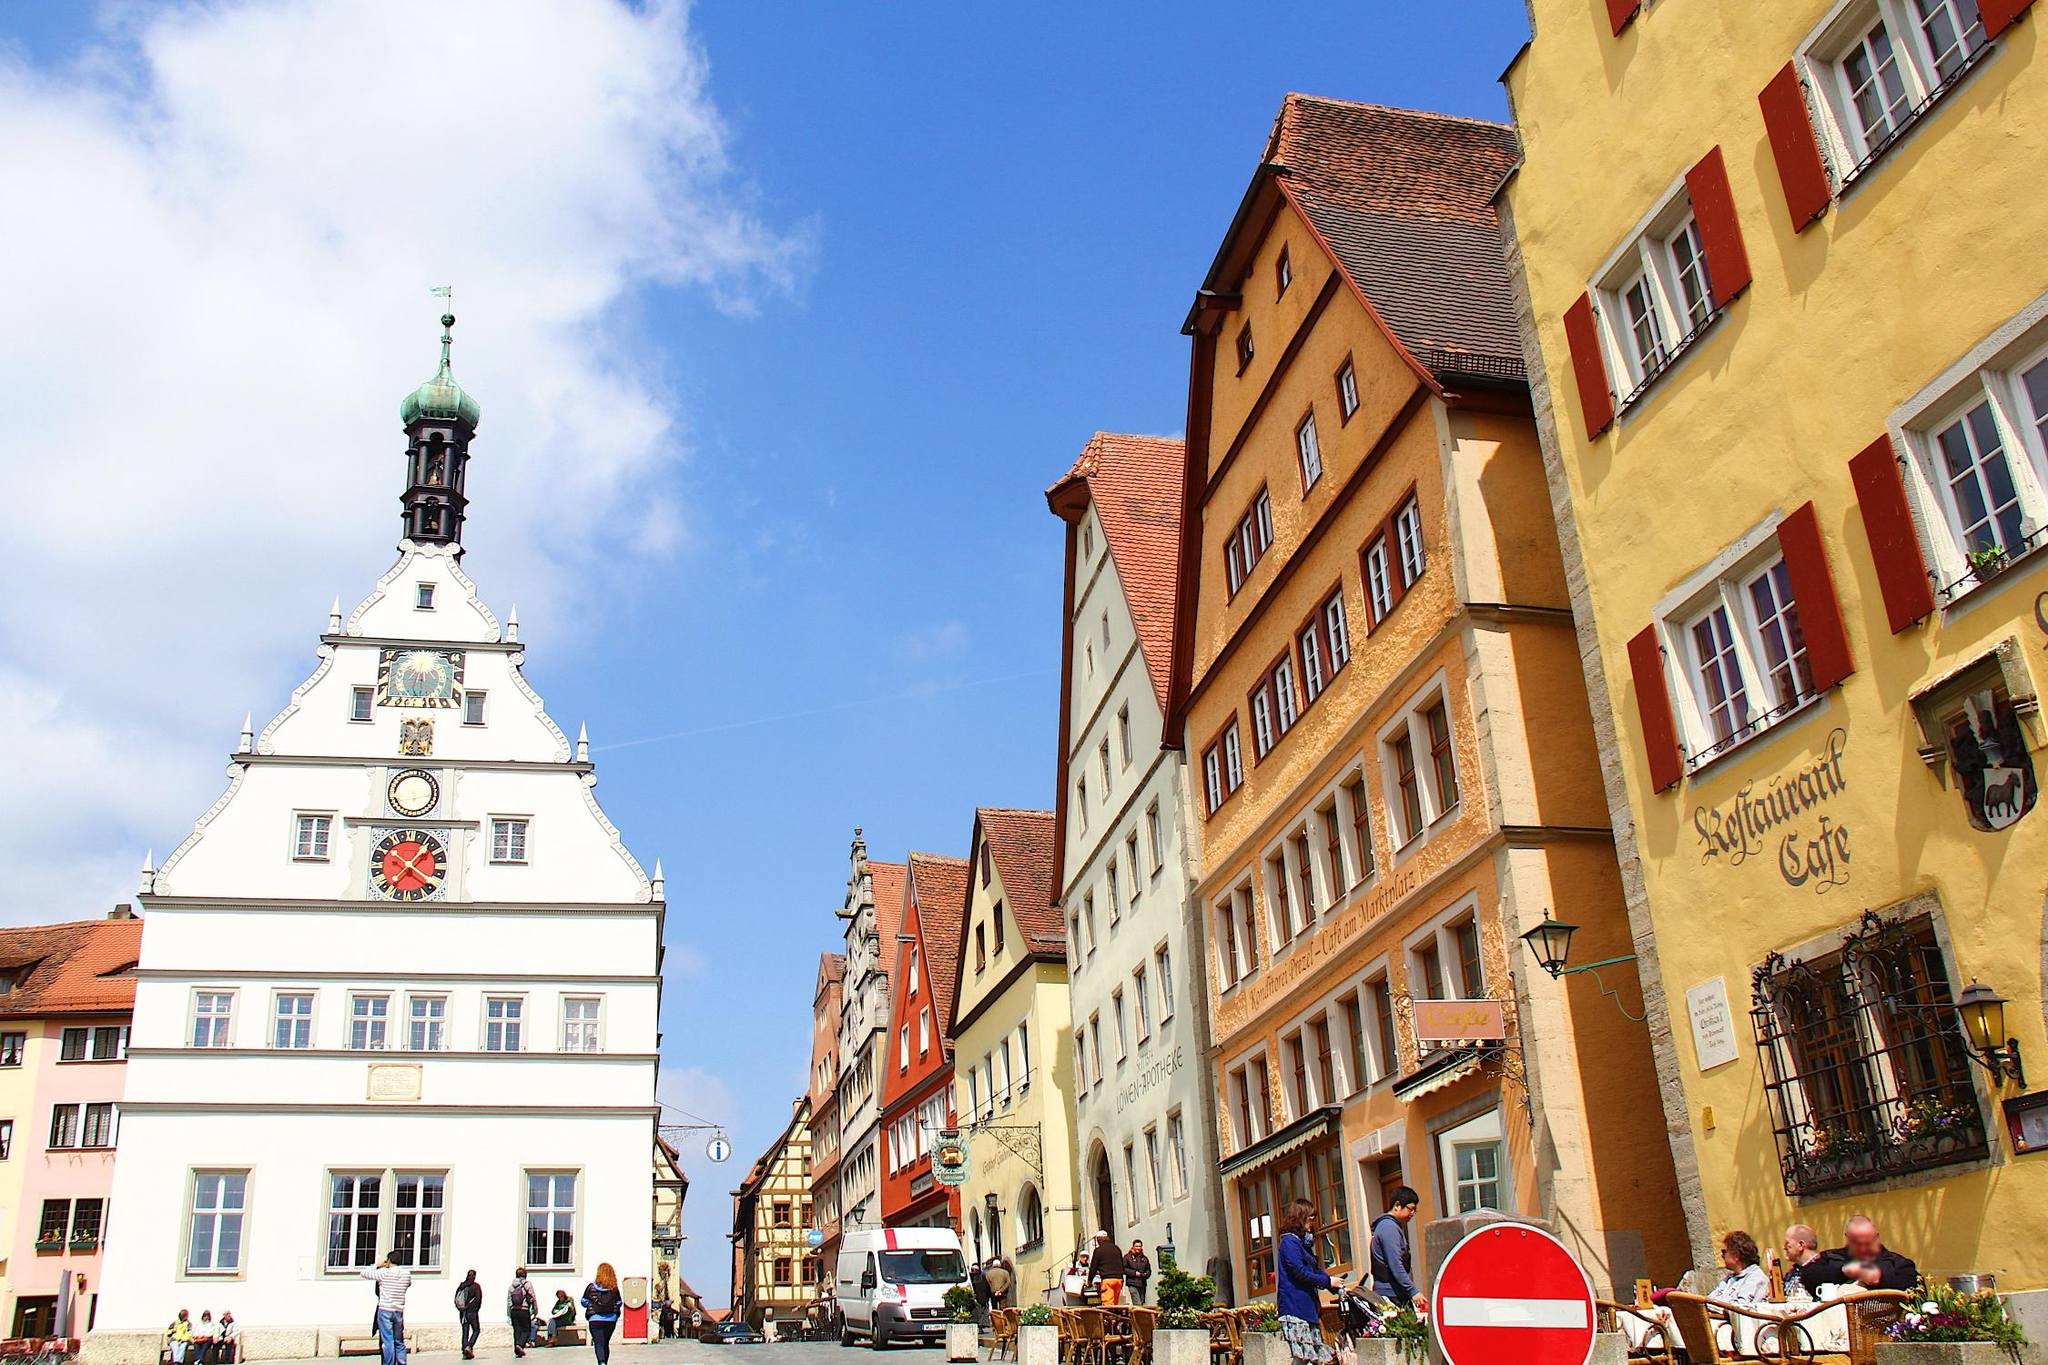What kinds of activities are people engaged in on this street? The street is bustling with varied activities; some people are enjoying meals and drinks at the cafe, taking advantage of the outdoor seating to soak in the ambience. Others are walking dogs or shopping, visiting small boutique shops that line the street. Photographers and tourists can also be seen capturing the picturesque setting, creating memories of their visit. 